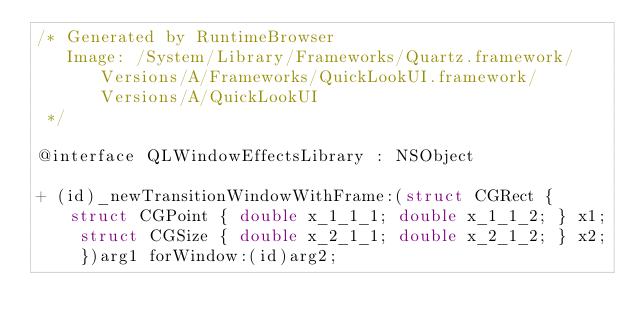Convert code to text. <code><loc_0><loc_0><loc_500><loc_500><_C_>/* Generated by RuntimeBrowser
   Image: /System/Library/Frameworks/Quartz.framework/Versions/A/Frameworks/QuickLookUI.framework/Versions/A/QuickLookUI
 */

@interface QLWindowEffectsLibrary : NSObject

+ (id)_newTransitionWindowWithFrame:(struct CGRect { struct CGPoint { double x_1_1_1; double x_1_1_2; } x1; struct CGSize { double x_2_1_1; double x_2_1_2; } x2; })arg1 forWindow:(id)arg2;</code> 